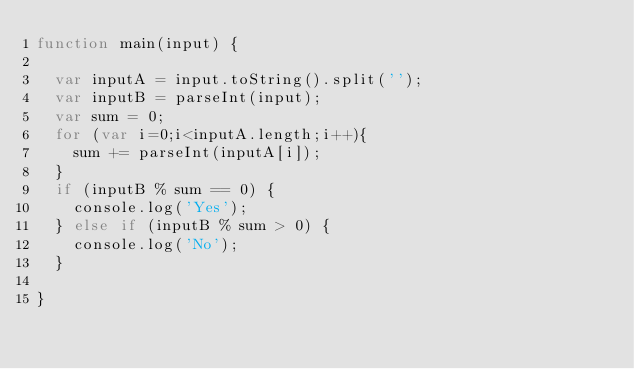<code> <loc_0><loc_0><loc_500><loc_500><_JavaScript_>function main(input) {
 
  var inputA = input.toString().split('');
  var inputB = parseInt(input);
  var sum = 0;
  for (var i=0;i<inputA.length;i++){
   	sum += parseInt(inputA[i]);
  }
  if (inputB % sum == 0) {
  	console.log('Yes');
  } else if (inputB % sum > 0) {
  	console.log('No');
  }
  
}</code> 